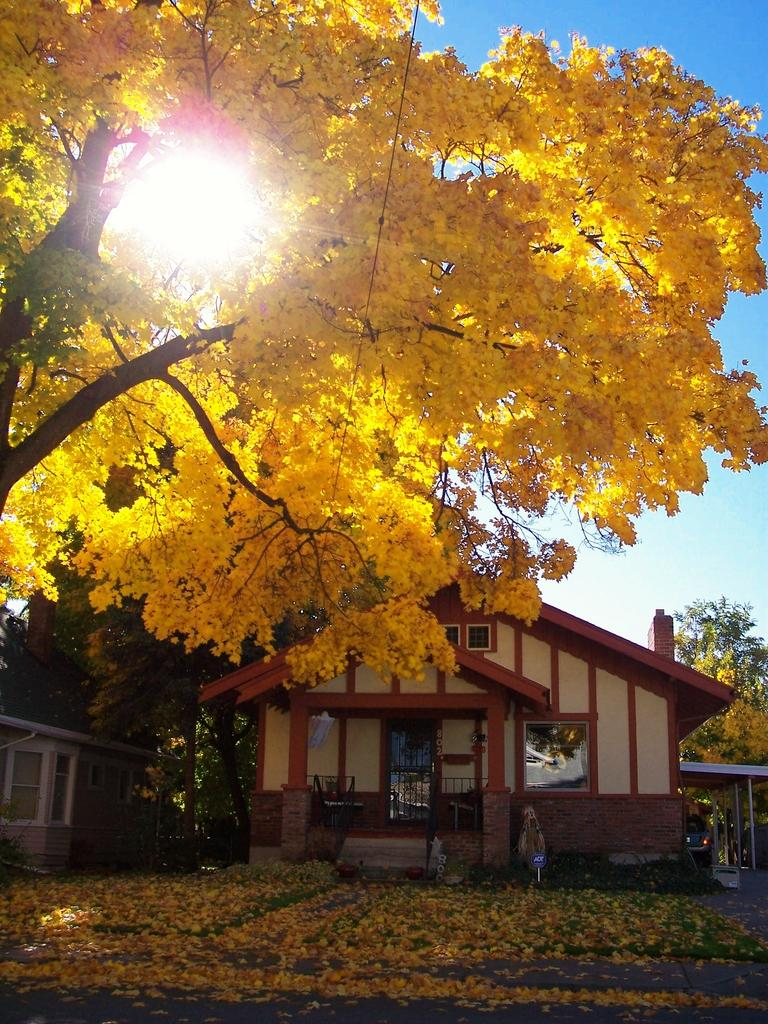What type of natural element is present in the image? There is a tree in the image. What is the color of the tree? The tree is yellow in color. What type of structures can be seen in the image? There are houses in the image. What can be seen in the background of the image? There is a sky visible in the background of the image. What celestial body is observable in the sky? The sun is observable in the sky. How does the tree twist around in the image? The tree does not twist around in the image; it is stationary and its color is yellow. What type of power source can be seen in the image? There is no power source visible in the image; it features a yellow tree and houses. 